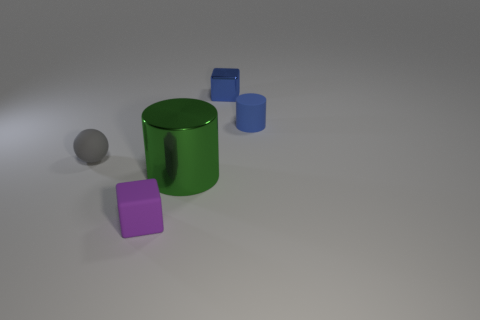What can the arrangement of these objects suggest about their purpose? The scattered arrangement of the objects, which include a cylinder, a cube, and a sphere, suggests a setting that might be used for educational or demonstrative purposes, possibly to showcase the properties of different geometric shapes or to compare the effects of lighting on various surfaces. 